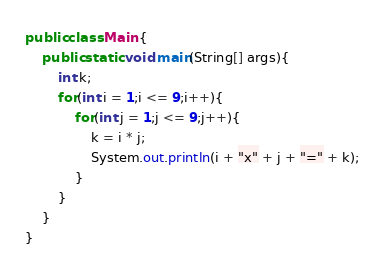<code> <loc_0><loc_0><loc_500><loc_500><_Java_>public class Main {
    public static void main(String[] args){
    	int k;
    	for(int i = 1;i <= 9;i++){
    		for(int j = 1;j <= 9;j++){
    			k = i * j;
    			System.out.println(i + "x" + j + "=" + k);
    		}
    	}
    }
}</code> 